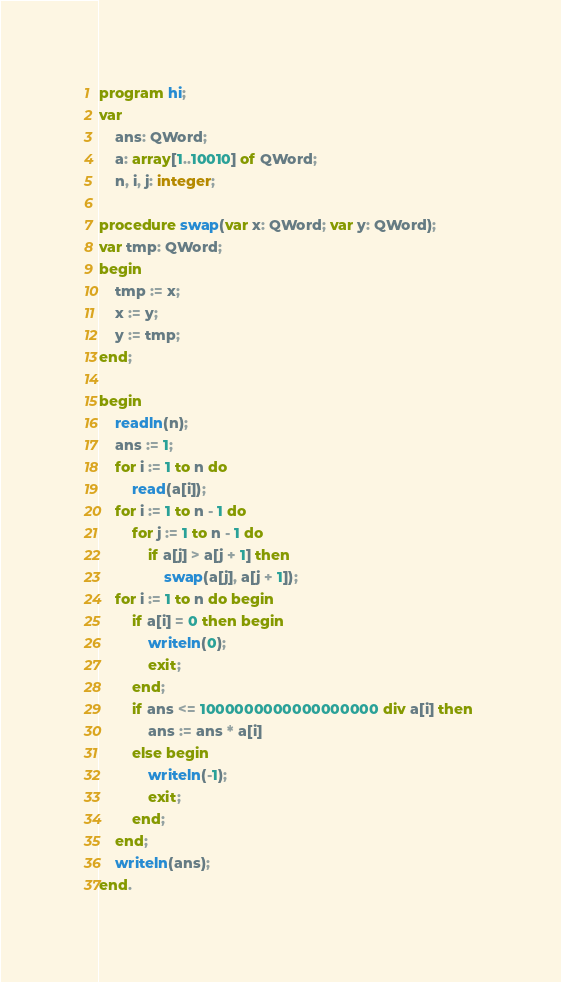<code> <loc_0><loc_0><loc_500><loc_500><_Pascal_>program hi;
var 
    ans: QWord;
    a: array[1..10010] of QWord;
    n, i, j: integer;

procedure swap(var x: QWord; var y: QWord);
var tmp: QWord;
begin
    tmp := x;
    x := y;
    y := tmp;
end;

begin
    readln(n);
    ans := 1;
    for i := 1 to n do 
        read(a[i]);
    for i := 1 to n - 1 do
        for j := 1 to n - 1 do 
            if a[j] > a[j + 1] then
                swap(a[j], a[j + 1]);
    for i := 1 to n do begin
        if a[i] = 0 then begin
            writeln(0);
            exit;
        end;
        if ans <= 1000000000000000000 div a[i] then 
            ans := ans * a[i]
        else begin
            writeln(-1);
            exit;
        end;
    end;
    writeln(ans);
end.</code> 